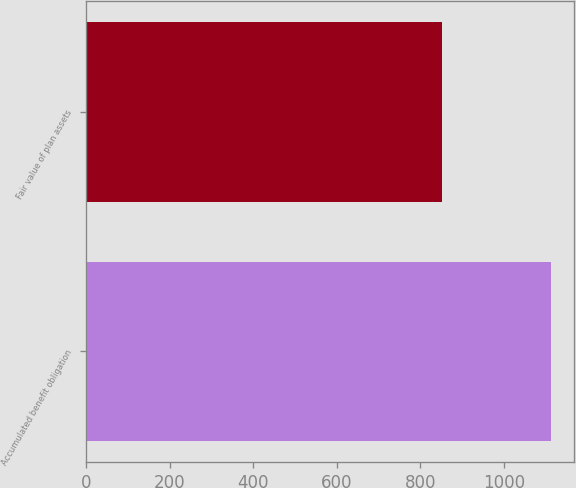<chart> <loc_0><loc_0><loc_500><loc_500><bar_chart><fcel>Accumulated benefit obligation<fcel>Fair value of plan assets<nl><fcel>1113<fcel>851<nl></chart> 